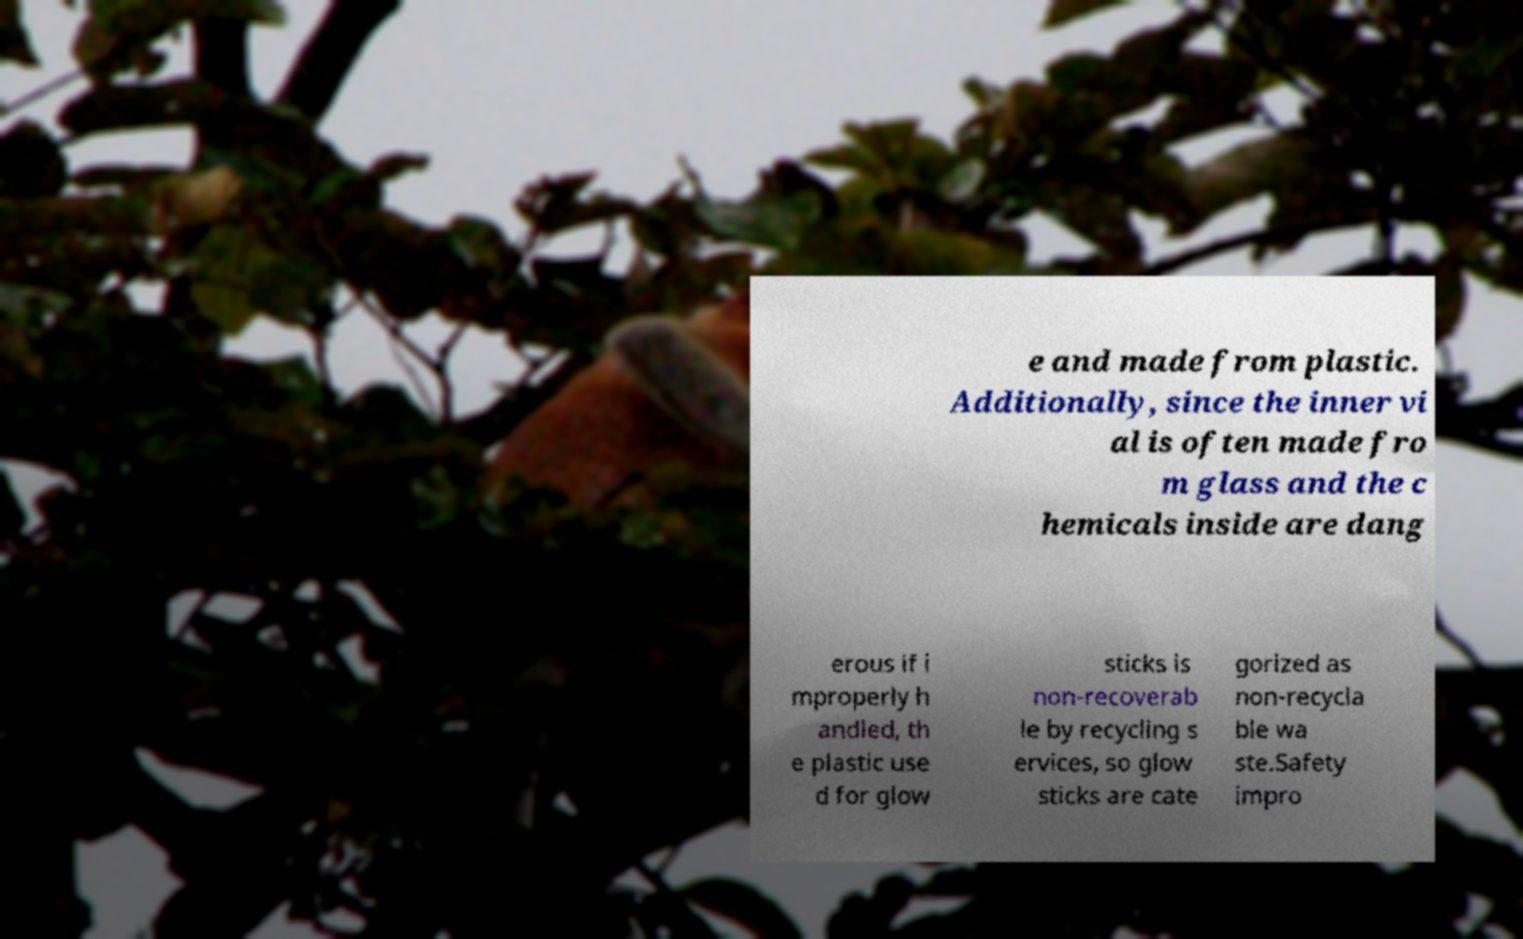What messages or text are displayed in this image? I need them in a readable, typed format. e and made from plastic. Additionally, since the inner vi al is often made fro m glass and the c hemicals inside are dang erous if i mproperly h andled, th e plastic use d for glow sticks is non-recoverab le by recycling s ervices, so glow sticks are cate gorized as non-recycla ble wa ste.Safety impro 